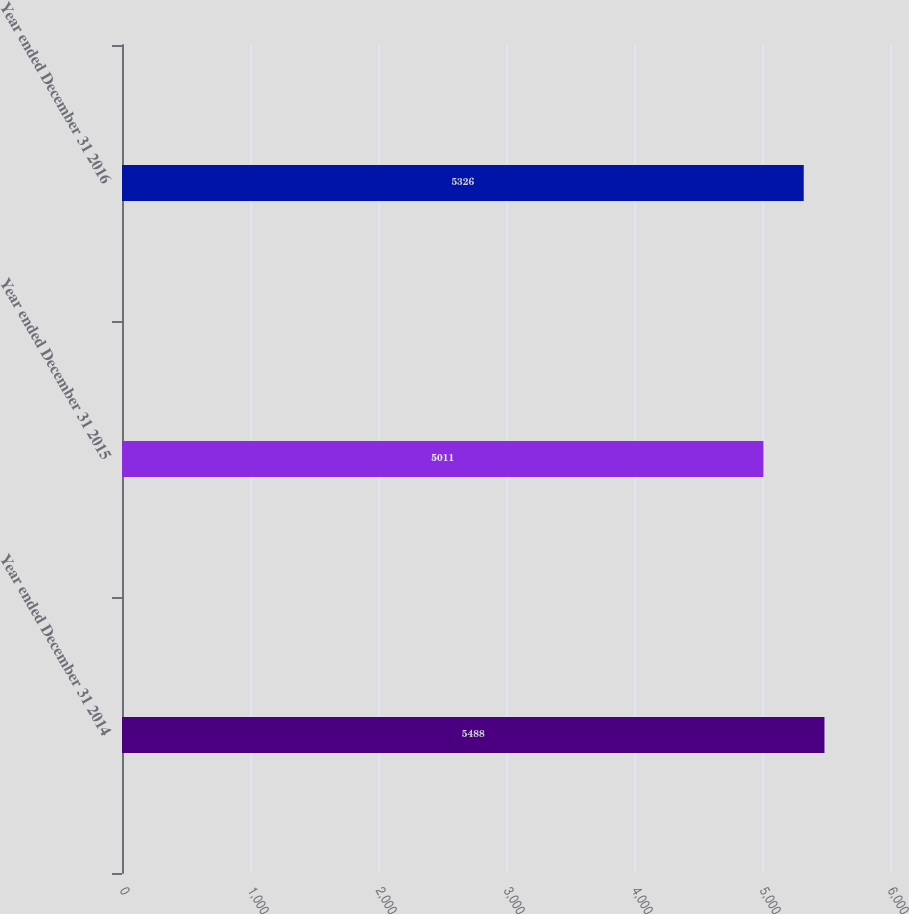Convert chart. <chart><loc_0><loc_0><loc_500><loc_500><bar_chart><fcel>Year ended December 31 2014<fcel>Year ended December 31 2015<fcel>Year ended December 31 2016<nl><fcel>5488<fcel>5011<fcel>5326<nl></chart> 